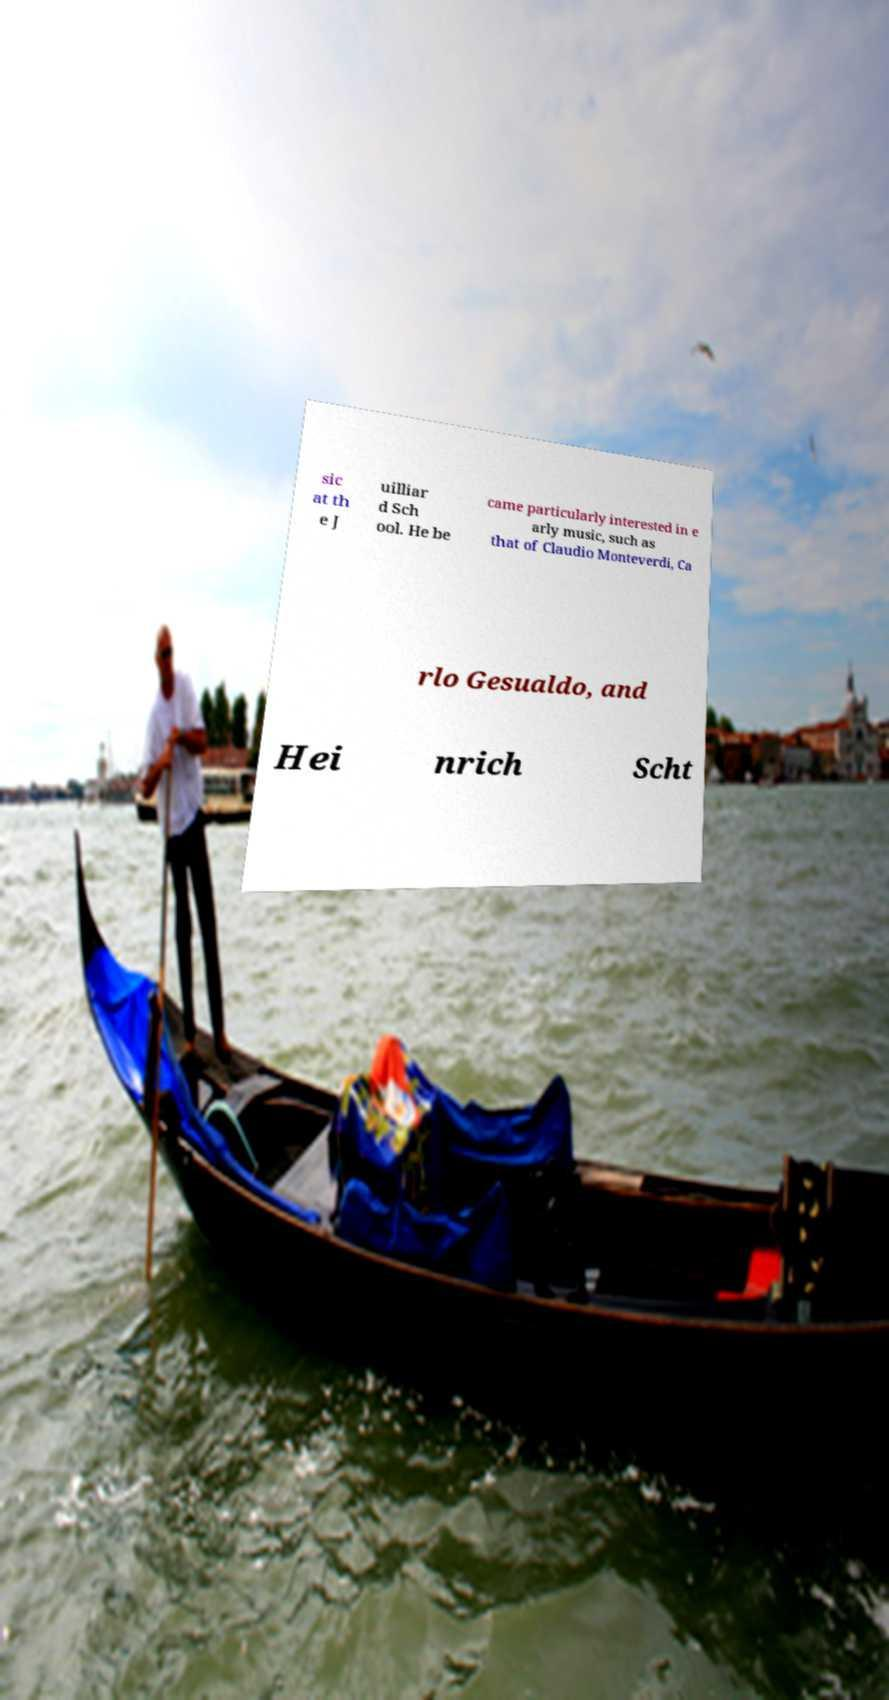Can you accurately transcribe the text from the provided image for me? sic at th e J uilliar d Sch ool. He be came particularly interested in e arly music, such as that of Claudio Monteverdi, Ca rlo Gesualdo, and Hei nrich Scht 